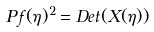<formula> <loc_0><loc_0><loc_500><loc_500>P \, f ( \eta ) ^ { 2 } = D e t ( X ( \eta ) )</formula> 